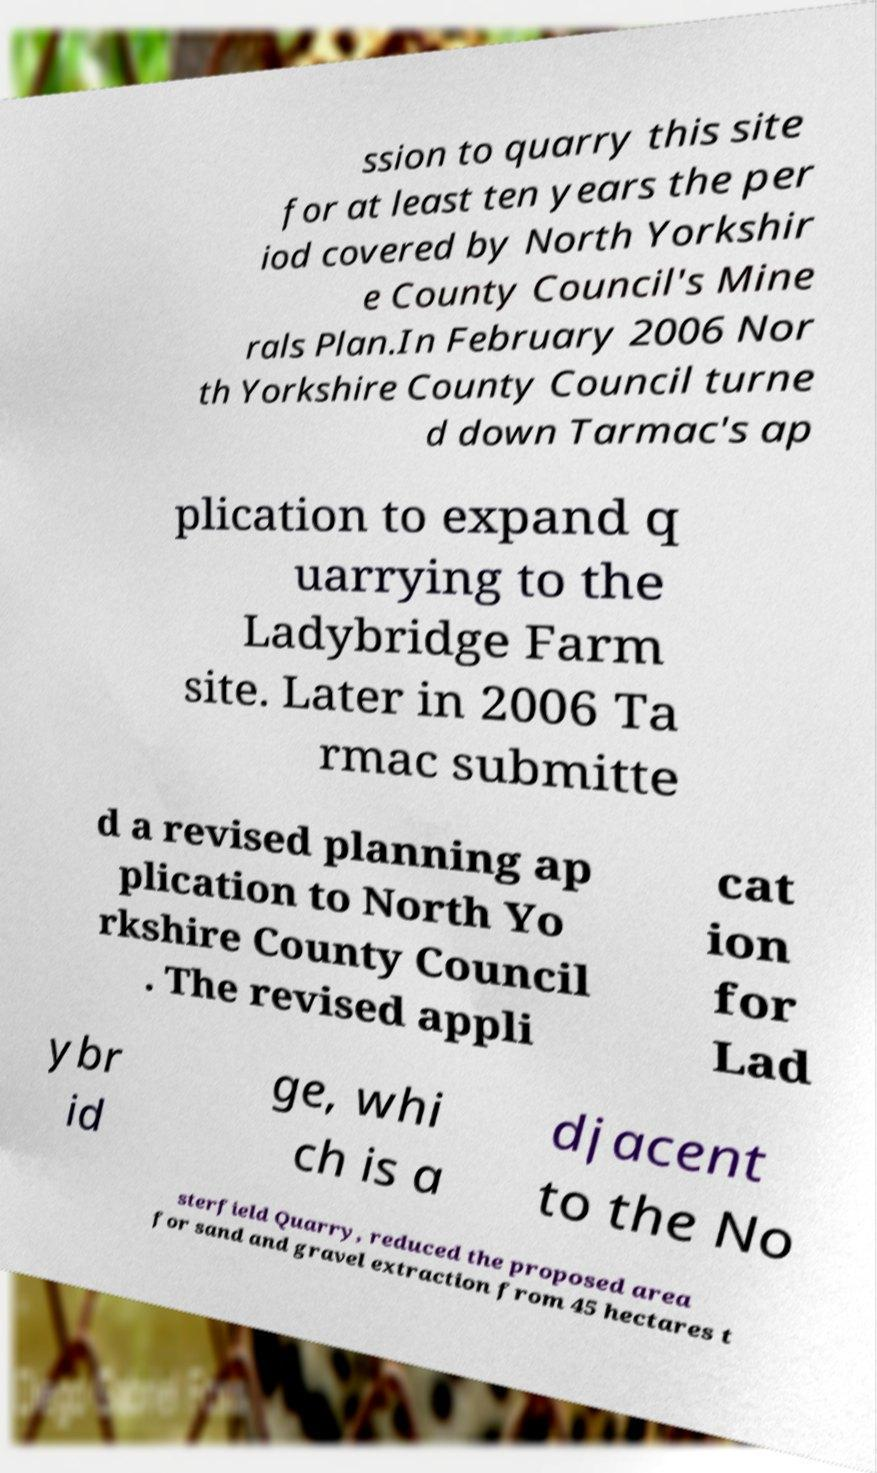I need the written content from this picture converted into text. Can you do that? ssion to quarry this site for at least ten years the per iod covered by North Yorkshir e County Council's Mine rals Plan.In February 2006 Nor th Yorkshire County Council turne d down Tarmac's ap plication to expand q uarrying to the Ladybridge Farm site. Later in 2006 Ta rmac submitte d a revised planning ap plication to North Yo rkshire County Council . The revised appli cat ion for Lad ybr id ge, whi ch is a djacent to the No sterfield Quarry, reduced the proposed area for sand and gravel extraction from 45 hectares t 